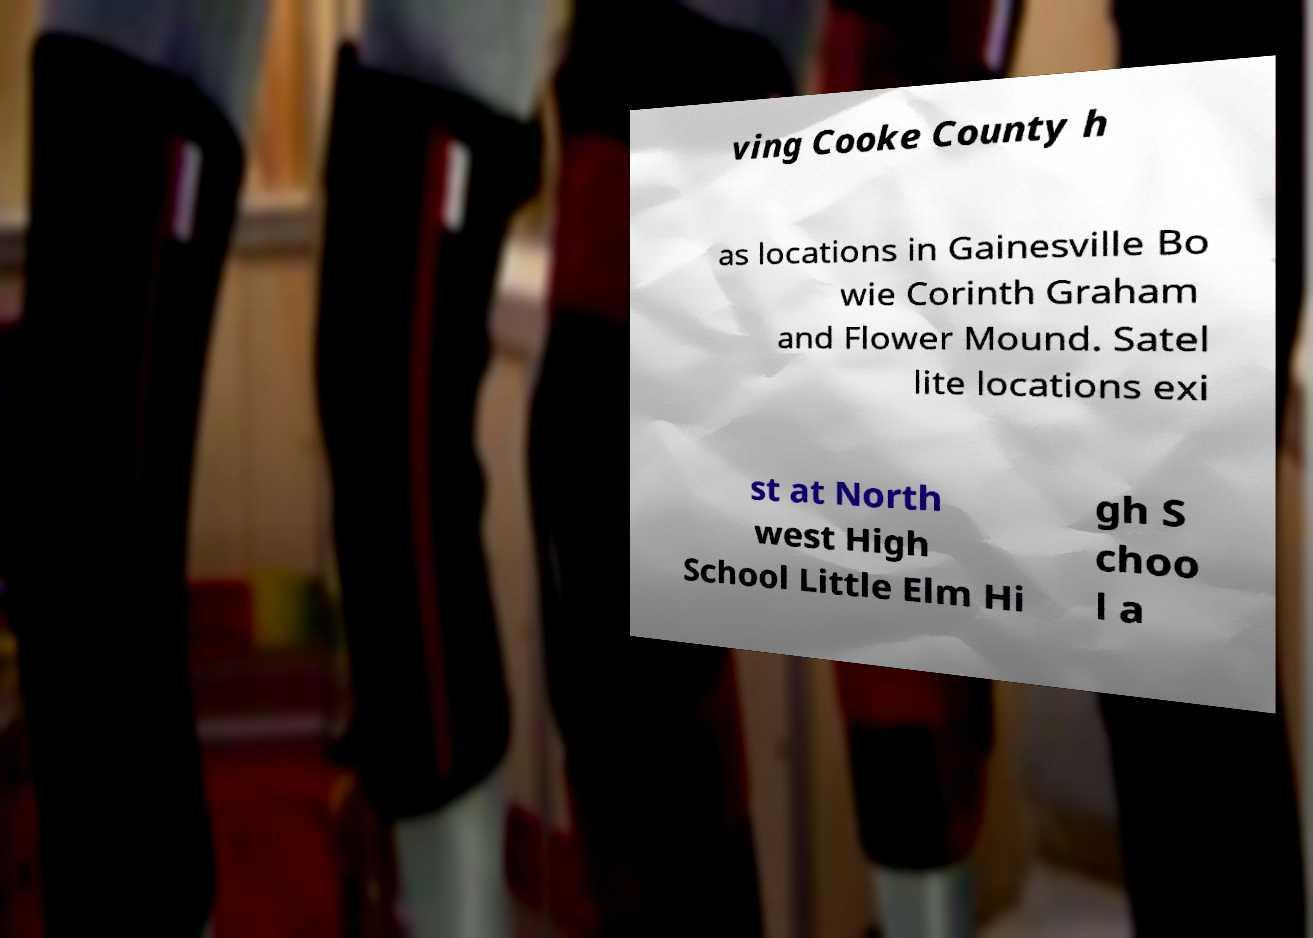For documentation purposes, I need the text within this image transcribed. Could you provide that? ving Cooke County h as locations in Gainesville Bo wie Corinth Graham and Flower Mound. Satel lite locations exi st at North west High School Little Elm Hi gh S choo l a 